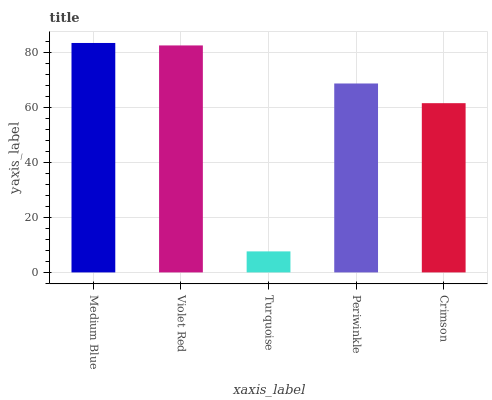Is Turquoise the minimum?
Answer yes or no. Yes. Is Medium Blue the maximum?
Answer yes or no. Yes. Is Violet Red the minimum?
Answer yes or no. No. Is Violet Red the maximum?
Answer yes or no. No. Is Medium Blue greater than Violet Red?
Answer yes or no. Yes. Is Violet Red less than Medium Blue?
Answer yes or no. Yes. Is Violet Red greater than Medium Blue?
Answer yes or no. No. Is Medium Blue less than Violet Red?
Answer yes or no. No. Is Periwinkle the high median?
Answer yes or no. Yes. Is Periwinkle the low median?
Answer yes or no. Yes. Is Crimson the high median?
Answer yes or no. No. Is Violet Red the low median?
Answer yes or no. No. 